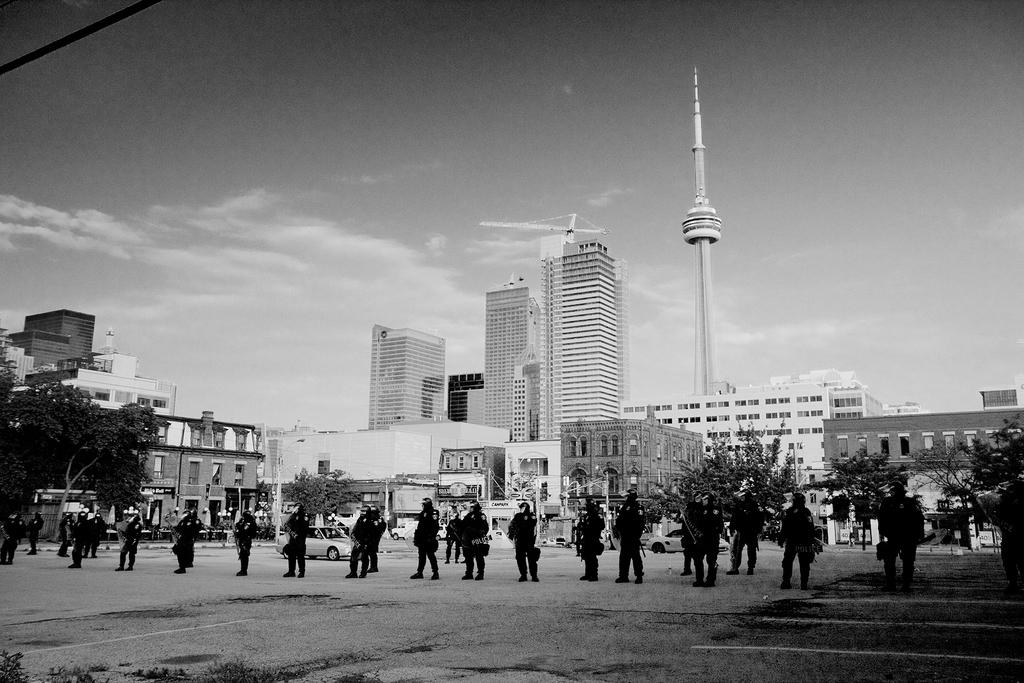What is the color scheme of the image? The image is black and white. What can be seen in the foreground of the image? There are people in the foreground of the image. What other objects or structures are present in the image? There are vehicles, trees, houses, buildings, and a tower in the image. What type of card is being used to defuse the bomb in the image? There is no card or bomb present in the image; it is a black and white image featuring people, vehicles, trees, houses, buildings, and a tower. 